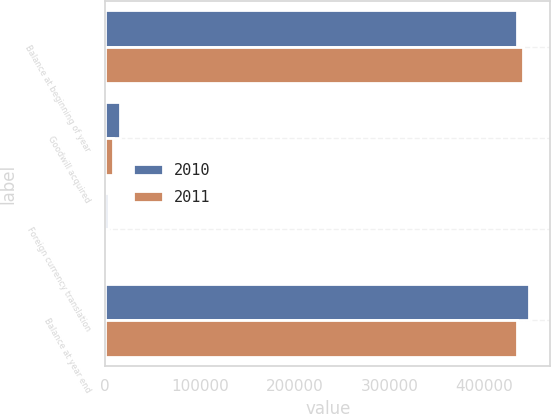<chart> <loc_0><loc_0><loc_500><loc_500><stacked_bar_chart><ecel><fcel>Balance at beginning of year<fcel>Goodwill acquired<fcel>Foreign currency translation<fcel>Balance at year end<nl><fcel>2010<fcel>434699<fcel>15425<fcel>2381<fcel>447743<nl><fcel>2011<fcel>440950<fcel>7778<fcel>1077<fcel>434699<nl></chart> 